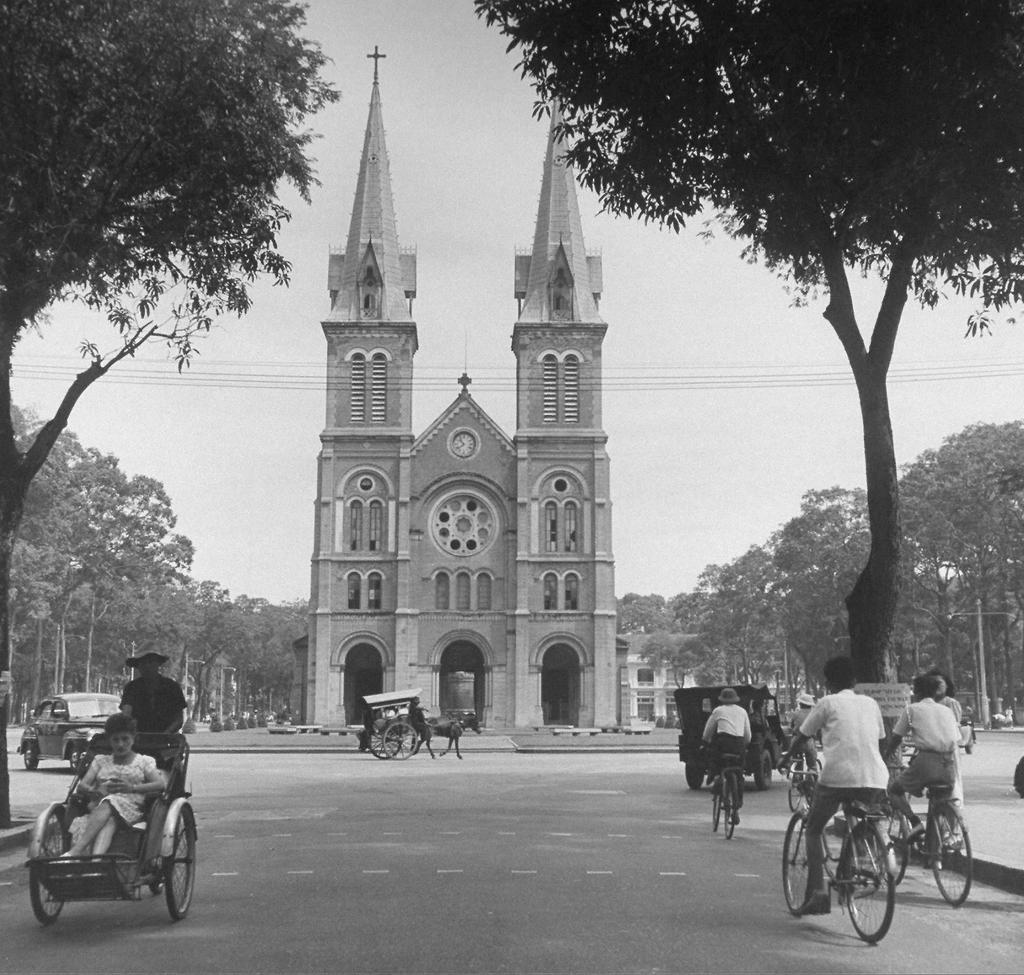What is the main subject in the center of the image? There is a building in the center of the image. What can be seen on the road in the image? There are vehicles on the road. What type of transportation is also present in the image? There is a horse cart in the image. What can be seen in the background of the image? There are trees, wires, and the sky visible in the background of the image. What type of leather is being used to make the fruit lock in the image? There is no leather or fruit lock present in the image. 